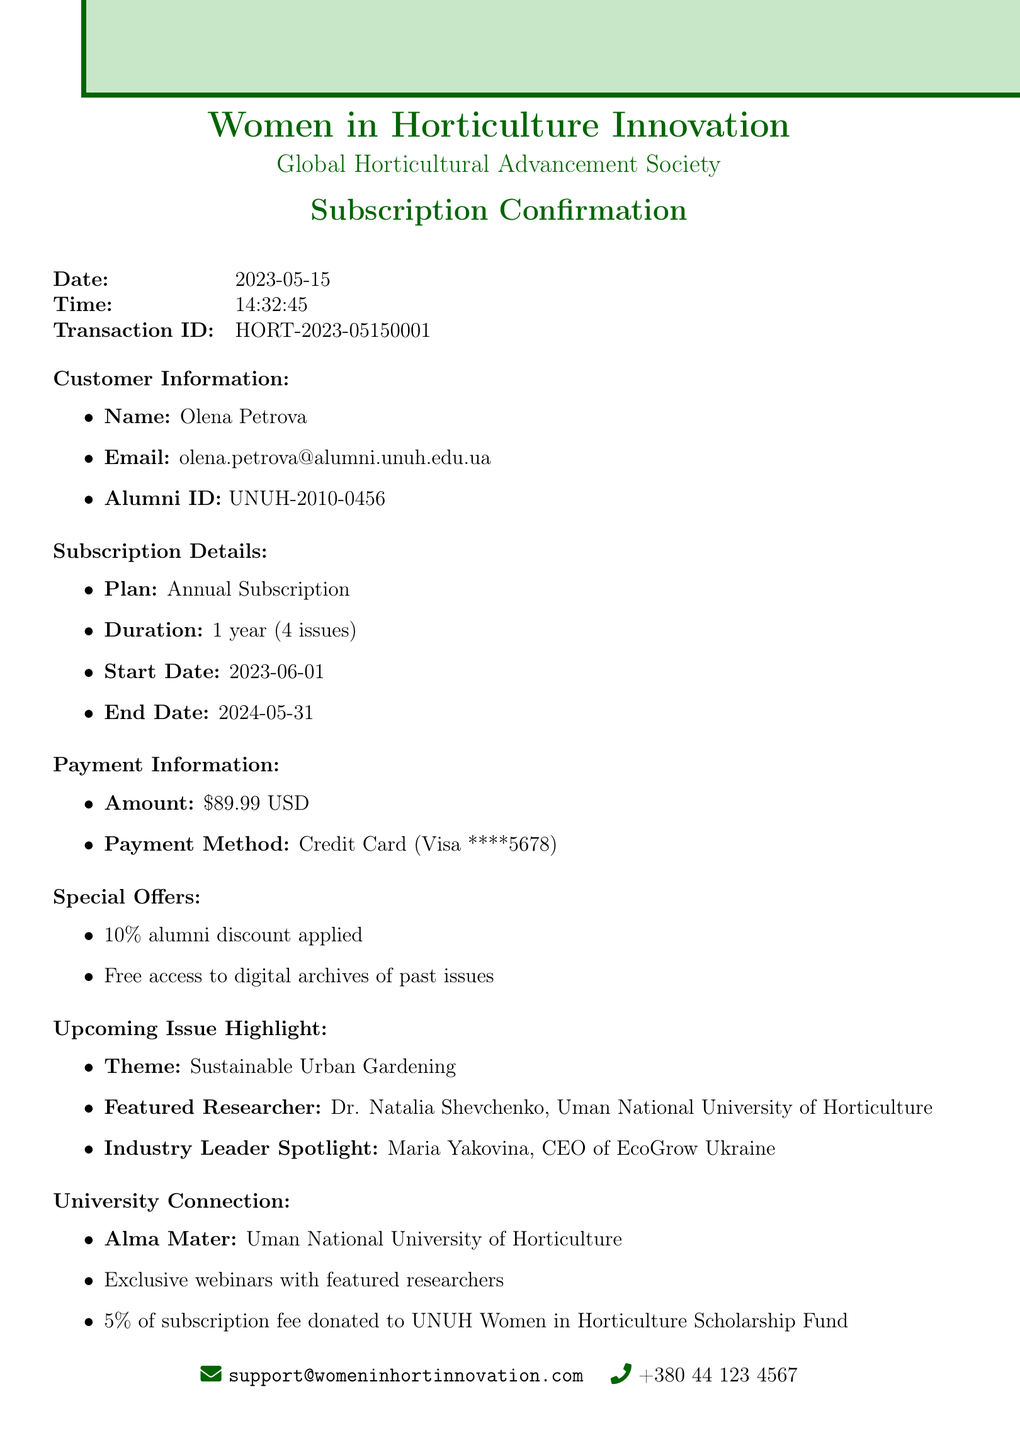What is the transaction ID? The transaction ID is a unique identifier for the transaction, found in the document.
Answer: HORT-2023-05150001 Who is the featured researcher in the upcoming issue? The featured researcher is specifically mentioned in the document under the upcoming issue highlight section.
Answer: Dr. Natalia Shevchenko What is the total payment amount? The total payment amount is listed in the payment information section of the document.
Answer: $89.99 What is the subscription plan? The subscription plan is explicitly stated in the subscription details section.
Answer: Annual Subscription When does the subscription start? The start date of the subscription is clearly mentioned in the subscription details section.
Answer: 2023-06-01 What benefits do alumni receive? The alumni benefits are described in the university connection section, referring to the exclusive offerings.
Answer: Exclusive webinars with featured researchers What is the main focus of the magazine? The main focus is indicated in the magazine details section, highlighting the content emphasis.
Answer: Innovations in horticulture with emphasis on female researchers and industry leaders How much is the alumni discount applied? The alumni discount percentage is mentioned in the special offers section of the document.
Answer: 10% What is the duration of the subscription? The duration is precisely defined in the subscription details section, explaining the timeframe of the subscription.
Answer: 1 year (4 issues) 